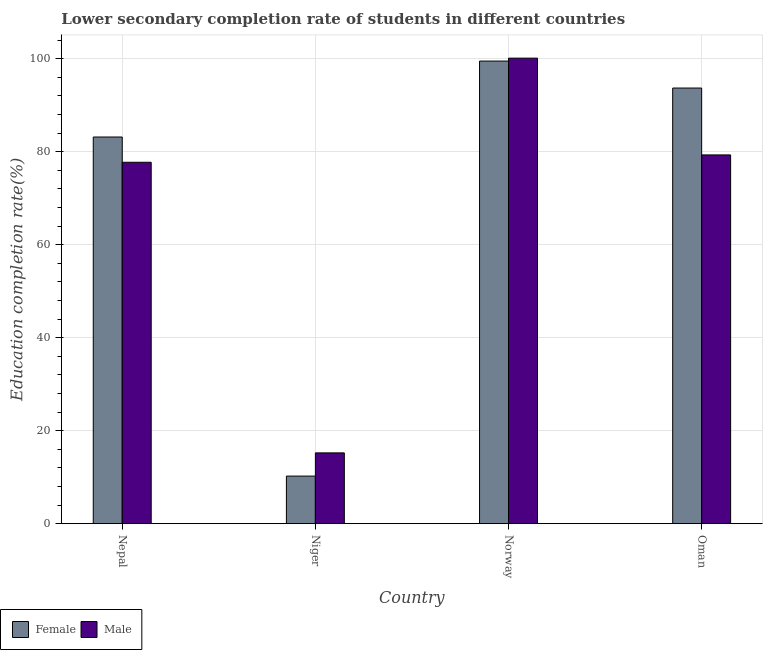How many groups of bars are there?
Offer a terse response. 4. Are the number of bars on each tick of the X-axis equal?
Offer a terse response. Yes. What is the label of the 2nd group of bars from the left?
Your answer should be very brief. Niger. What is the education completion rate of male students in Niger?
Ensure brevity in your answer.  15.22. Across all countries, what is the maximum education completion rate of male students?
Your answer should be very brief. 100.14. Across all countries, what is the minimum education completion rate of male students?
Make the answer very short. 15.22. In which country was the education completion rate of female students minimum?
Provide a succinct answer. Niger. What is the total education completion rate of male students in the graph?
Your response must be concise. 272.42. What is the difference between the education completion rate of female students in Nepal and that in Norway?
Offer a terse response. -16.34. What is the difference between the education completion rate of female students in Niger and the education completion rate of male students in Norway?
Offer a very short reply. -89.91. What is the average education completion rate of female students per country?
Make the answer very short. 71.66. What is the difference between the education completion rate of male students and education completion rate of female students in Norway?
Your answer should be compact. 0.63. What is the ratio of the education completion rate of female students in Nepal to that in Norway?
Your answer should be compact. 0.84. What is the difference between the highest and the second highest education completion rate of male students?
Make the answer very short. 20.82. What is the difference between the highest and the lowest education completion rate of female students?
Keep it short and to the point. 89.28. Is the sum of the education completion rate of male students in Niger and Norway greater than the maximum education completion rate of female students across all countries?
Provide a succinct answer. Yes. How many countries are there in the graph?
Your answer should be very brief. 4. Does the graph contain grids?
Ensure brevity in your answer.  Yes. How many legend labels are there?
Ensure brevity in your answer.  2. What is the title of the graph?
Your response must be concise. Lower secondary completion rate of students in different countries. What is the label or title of the X-axis?
Your answer should be compact. Country. What is the label or title of the Y-axis?
Provide a succinct answer. Education completion rate(%). What is the Education completion rate(%) in Female in Nepal?
Offer a very short reply. 83.17. What is the Education completion rate(%) of Male in Nepal?
Provide a succinct answer. 77.74. What is the Education completion rate(%) in Female in Niger?
Your answer should be compact. 10.23. What is the Education completion rate(%) in Male in Niger?
Provide a succinct answer. 15.22. What is the Education completion rate(%) in Female in Norway?
Ensure brevity in your answer.  99.51. What is the Education completion rate(%) of Male in Norway?
Your answer should be very brief. 100.14. What is the Education completion rate(%) of Female in Oman?
Keep it short and to the point. 93.71. What is the Education completion rate(%) of Male in Oman?
Make the answer very short. 79.32. Across all countries, what is the maximum Education completion rate(%) of Female?
Your answer should be compact. 99.51. Across all countries, what is the maximum Education completion rate(%) in Male?
Your answer should be compact. 100.14. Across all countries, what is the minimum Education completion rate(%) in Female?
Make the answer very short. 10.23. Across all countries, what is the minimum Education completion rate(%) of Male?
Your response must be concise. 15.22. What is the total Education completion rate(%) of Female in the graph?
Make the answer very short. 286.62. What is the total Education completion rate(%) of Male in the graph?
Ensure brevity in your answer.  272.42. What is the difference between the Education completion rate(%) in Female in Nepal and that in Niger?
Keep it short and to the point. 72.94. What is the difference between the Education completion rate(%) in Male in Nepal and that in Niger?
Keep it short and to the point. 62.52. What is the difference between the Education completion rate(%) of Female in Nepal and that in Norway?
Keep it short and to the point. -16.34. What is the difference between the Education completion rate(%) in Male in Nepal and that in Norway?
Make the answer very short. -22.4. What is the difference between the Education completion rate(%) of Female in Nepal and that in Oman?
Offer a terse response. -10.54. What is the difference between the Education completion rate(%) in Male in Nepal and that in Oman?
Keep it short and to the point. -1.58. What is the difference between the Education completion rate(%) in Female in Niger and that in Norway?
Provide a short and direct response. -89.28. What is the difference between the Education completion rate(%) in Male in Niger and that in Norway?
Your response must be concise. -84.91. What is the difference between the Education completion rate(%) of Female in Niger and that in Oman?
Your response must be concise. -83.48. What is the difference between the Education completion rate(%) in Male in Niger and that in Oman?
Offer a terse response. -64.1. What is the difference between the Education completion rate(%) in Female in Norway and that in Oman?
Your response must be concise. 5.8. What is the difference between the Education completion rate(%) in Male in Norway and that in Oman?
Ensure brevity in your answer.  20.82. What is the difference between the Education completion rate(%) of Female in Nepal and the Education completion rate(%) of Male in Niger?
Your answer should be very brief. 67.95. What is the difference between the Education completion rate(%) of Female in Nepal and the Education completion rate(%) of Male in Norway?
Provide a succinct answer. -16.96. What is the difference between the Education completion rate(%) of Female in Nepal and the Education completion rate(%) of Male in Oman?
Provide a succinct answer. 3.85. What is the difference between the Education completion rate(%) in Female in Niger and the Education completion rate(%) in Male in Norway?
Offer a terse response. -89.91. What is the difference between the Education completion rate(%) of Female in Niger and the Education completion rate(%) of Male in Oman?
Provide a short and direct response. -69.09. What is the difference between the Education completion rate(%) of Female in Norway and the Education completion rate(%) of Male in Oman?
Ensure brevity in your answer.  20.19. What is the average Education completion rate(%) in Female per country?
Ensure brevity in your answer.  71.66. What is the average Education completion rate(%) in Male per country?
Offer a terse response. 68.11. What is the difference between the Education completion rate(%) in Female and Education completion rate(%) in Male in Nepal?
Your answer should be compact. 5.43. What is the difference between the Education completion rate(%) of Female and Education completion rate(%) of Male in Niger?
Your answer should be compact. -4.99. What is the difference between the Education completion rate(%) in Female and Education completion rate(%) in Male in Norway?
Provide a succinct answer. -0.63. What is the difference between the Education completion rate(%) in Female and Education completion rate(%) in Male in Oman?
Ensure brevity in your answer.  14.39. What is the ratio of the Education completion rate(%) of Female in Nepal to that in Niger?
Make the answer very short. 8.13. What is the ratio of the Education completion rate(%) in Male in Nepal to that in Niger?
Offer a very short reply. 5.11. What is the ratio of the Education completion rate(%) in Female in Nepal to that in Norway?
Offer a terse response. 0.84. What is the ratio of the Education completion rate(%) in Male in Nepal to that in Norway?
Keep it short and to the point. 0.78. What is the ratio of the Education completion rate(%) of Female in Nepal to that in Oman?
Keep it short and to the point. 0.89. What is the ratio of the Education completion rate(%) of Male in Nepal to that in Oman?
Give a very brief answer. 0.98. What is the ratio of the Education completion rate(%) in Female in Niger to that in Norway?
Your response must be concise. 0.1. What is the ratio of the Education completion rate(%) in Male in Niger to that in Norway?
Give a very brief answer. 0.15. What is the ratio of the Education completion rate(%) in Female in Niger to that in Oman?
Make the answer very short. 0.11. What is the ratio of the Education completion rate(%) in Male in Niger to that in Oman?
Offer a terse response. 0.19. What is the ratio of the Education completion rate(%) in Female in Norway to that in Oman?
Keep it short and to the point. 1.06. What is the ratio of the Education completion rate(%) in Male in Norway to that in Oman?
Your response must be concise. 1.26. What is the difference between the highest and the second highest Education completion rate(%) of Female?
Your response must be concise. 5.8. What is the difference between the highest and the second highest Education completion rate(%) of Male?
Your response must be concise. 20.82. What is the difference between the highest and the lowest Education completion rate(%) of Female?
Make the answer very short. 89.28. What is the difference between the highest and the lowest Education completion rate(%) in Male?
Offer a terse response. 84.91. 